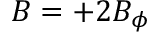Convert formula to latex. <formula><loc_0><loc_0><loc_500><loc_500>B = + 2 B _ { \phi }</formula> 